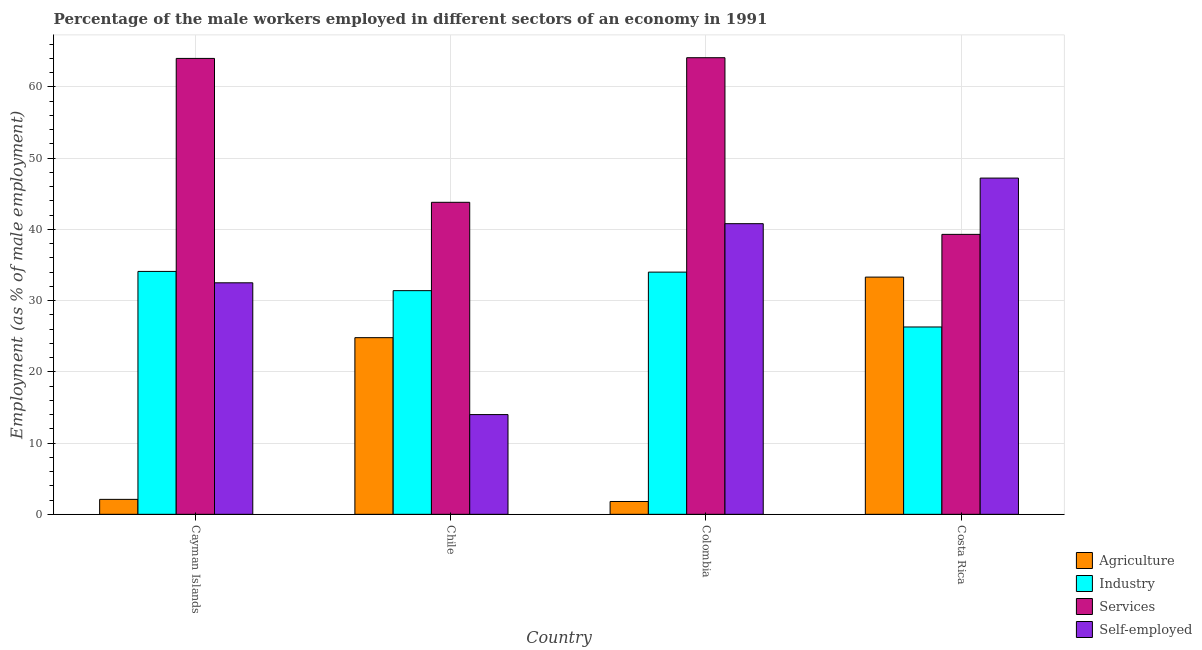How many different coloured bars are there?
Offer a very short reply. 4. Are the number of bars per tick equal to the number of legend labels?
Provide a short and direct response. Yes. Are the number of bars on each tick of the X-axis equal?
Keep it short and to the point. Yes. How many bars are there on the 4th tick from the left?
Provide a short and direct response. 4. How many bars are there on the 4th tick from the right?
Provide a succinct answer. 4. In how many cases, is the number of bars for a given country not equal to the number of legend labels?
Your answer should be compact. 0. What is the percentage of male workers in agriculture in Colombia?
Make the answer very short. 1.8. Across all countries, what is the maximum percentage of male workers in industry?
Offer a terse response. 34.1. In which country was the percentage of male workers in agriculture maximum?
Ensure brevity in your answer.  Costa Rica. In which country was the percentage of male workers in services minimum?
Offer a terse response. Costa Rica. What is the total percentage of male workers in agriculture in the graph?
Provide a succinct answer. 62. What is the difference between the percentage of self employed male workers in Chile and that in Costa Rica?
Provide a short and direct response. -33.2. What is the difference between the percentage of male workers in industry in Cayman Islands and the percentage of self employed male workers in Colombia?
Your answer should be compact. -6.7. What is the average percentage of male workers in services per country?
Give a very brief answer. 52.8. What is the difference between the percentage of male workers in services and percentage of male workers in industry in Chile?
Provide a short and direct response. 12.4. In how many countries, is the percentage of male workers in services greater than 28 %?
Your answer should be compact. 4. What is the ratio of the percentage of male workers in services in Cayman Islands to that in Costa Rica?
Your response must be concise. 1.63. Is the percentage of self employed male workers in Cayman Islands less than that in Costa Rica?
Keep it short and to the point. Yes. Is the difference between the percentage of male workers in agriculture in Colombia and Costa Rica greater than the difference between the percentage of male workers in services in Colombia and Costa Rica?
Offer a terse response. No. What is the difference between the highest and the second highest percentage of self employed male workers?
Provide a short and direct response. 6.4. What is the difference between the highest and the lowest percentage of self employed male workers?
Keep it short and to the point. 33.2. In how many countries, is the percentage of male workers in services greater than the average percentage of male workers in services taken over all countries?
Your answer should be very brief. 2. Is it the case that in every country, the sum of the percentage of self employed male workers and percentage of male workers in agriculture is greater than the sum of percentage of male workers in services and percentage of male workers in industry?
Provide a succinct answer. No. What does the 1st bar from the left in Chile represents?
Your response must be concise. Agriculture. What does the 4th bar from the right in Cayman Islands represents?
Give a very brief answer. Agriculture. Are all the bars in the graph horizontal?
Ensure brevity in your answer.  No. What is the difference between two consecutive major ticks on the Y-axis?
Your response must be concise. 10. Are the values on the major ticks of Y-axis written in scientific E-notation?
Ensure brevity in your answer.  No. Does the graph contain grids?
Provide a short and direct response. Yes. How many legend labels are there?
Keep it short and to the point. 4. What is the title of the graph?
Your response must be concise. Percentage of the male workers employed in different sectors of an economy in 1991. Does "Methodology assessment" appear as one of the legend labels in the graph?
Ensure brevity in your answer.  No. What is the label or title of the X-axis?
Offer a very short reply. Country. What is the label or title of the Y-axis?
Your response must be concise. Employment (as % of male employment). What is the Employment (as % of male employment) in Agriculture in Cayman Islands?
Make the answer very short. 2.1. What is the Employment (as % of male employment) in Industry in Cayman Islands?
Offer a terse response. 34.1. What is the Employment (as % of male employment) in Services in Cayman Islands?
Your response must be concise. 64. What is the Employment (as % of male employment) of Self-employed in Cayman Islands?
Your answer should be compact. 32.5. What is the Employment (as % of male employment) in Agriculture in Chile?
Your response must be concise. 24.8. What is the Employment (as % of male employment) in Industry in Chile?
Your answer should be very brief. 31.4. What is the Employment (as % of male employment) of Services in Chile?
Your response must be concise. 43.8. What is the Employment (as % of male employment) in Agriculture in Colombia?
Your response must be concise. 1.8. What is the Employment (as % of male employment) of Industry in Colombia?
Ensure brevity in your answer.  34. What is the Employment (as % of male employment) of Services in Colombia?
Your answer should be very brief. 64.1. What is the Employment (as % of male employment) in Self-employed in Colombia?
Provide a short and direct response. 40.8. What is the Employment (as % of male employment) in Agriculture in Costa Rica?
Ensure brevity in your answer.  33.3. What is the Employment (as % of male employment) of Industry in Costa Rica?
Offer a terse response. 26.3. What is the Employment (as % of male employment) of Services in Costa Rica?
Offer a terse response. 39.3. What is the Employment (as % of male employment) of Self-employed in Costa Rica?
Make the answer very short. 47.2. Across all countries, what is the maximum Employment (as % of male employment) in Agriculture?
Make the answer very short. 33.3. Across all countries, what is the maximum Employment (as % of male employment) of Industry?
Keep it short and to the point. 34.1. Across all countries, what is the maximum Employment (as % of male employment) in Services?
Make the answer very short. 64.1. Across all countries, what is the maximum Employment (as % of male employment) of Self-employed?
Your response must be concise. 47.2. Across all countries, what is the minimum Employment (as % of male employment) in Agriculture?
Your answer should be compact. 1.8. Across all countries, what is the minimum Employment (as % of male employment) in Industry?
Provide a succinct answer. 26.3. Across all countries, what is the minimum Employment (as % of male employment) of Services?
Your answer should be very brief. 39.3. Across all countries, what is the minimum Employment (as % of male employment) in Self-employed?
Provide a succinct answer. 14. What is the total Employment (as % of male employment) of Agriculture in the graph?
Keep it short and to the point. 62. What is the total Employment (as % of male employment) of Industry in the graph?
Provide a short and direct response. 125.8. What is the total Employment (as % of male employment) in Services in the graph?
Your answer should be very brief. 211.2. What is the total Employment (as % of male employment) of Self-employed in the graph?
Your answer should be compact. 134.5. What is the difference between the Employment (as % of male employment) in Agriculture in Cayman Islands and that in Chile?
Provide a succinct answer. -22.7. What is the difference between the Employment (as % of male employment) of Services in Cayman Islands and that in Chile?
Your answer should be compact. 20.2. What is the difference between the Employment (as % of male employment) of Agriculture in Cayman Islands and that in Colombia?
Provide a succinct answer. 0.3. What is the difference between the Employment (as % of male employment) of Industry in Cayman Islands and that in Colombia?
Provide a succinct answer. 0.1. What is the difference between the Employment (as % of male employment) in Self-employed in Cayman Islands and that in Colombia?
Your answer should be compact. -8.3. What is the difference between the Employment (as % of male employment) in Agriculture in Cayman Islands and that in Costa Rica?
Make the answer very short. -31.2. What is the difference between the Employment (as % of male employment) of Services in Cayman Islands and that in Costa Rica?
Provide a short and direct response. 24.7. What is the difference between the Employment (as % of male employment) of Self-employed in Cayman Islands and that in Costa Rica?
Keep it short and to the point. -14.7. What is the difference between the Employment (as % of male employment) of Agriculture in Chile and that in Colombia?
Keep it short and to the point. 23. What is the difference between the Employment (as % of male employment) in Industry in Chile and that in Colombia?
Provide a short and direct response. -2.6. What is the difference between the Employment (as % of male employment) of Services in Chile and that in Colombia?
Ensure brevity in your answer.  -20.3. What is the difference between the Employment (as % of male employment) in Self-employed in Chile and that in Colombia?
Provide a short and direct response. -26.8. What is the difference between the Employment (as % of male employment) in Agriculture in Chile and that in Costa Rica?
Ensure brevity in your answer.  -8.5. What is the difference between the Employment (as % of male employment) of Industry in Chile and that in Costa Rica?
Your answer should be compact. 5.1. What is the difference between the Employment (as % of male employment) in Self-employed in Chile and that in Costa Rica?
Give a very brief answer. -33.2. What is the difference between the Employment (as % of male employment) in Agriculture in Colombia and that in Costa Rica?
Give a very brief answer. -31.5. What is the difference between the Employment (as % of male employment) of Industry in Colombia and that in Costa Rica?
Your response must be concise. 7.7. What is the difference between the Employment (as % of male employment) in Services in Colombia and that in Costa Rica?
Your answer should be very brief. 24.8. What is the difference between the Employment (as % of male employment) in Self-employed in Colombia and that in Costa Rica?
Give a very brief answer. -6.4. What is the difference between the Employment (as % of male employment) of Agriculture in Cayman Islands and the Employment (as % of male employment) of Industry in Chile?
Make the answer very short. -29.3. What is the difference between the Employment (as % of male employment) of Agriculture in Cayman Islands and the Employment (as % of male employment) of Services in Chile?
Make the answer very short. -41.7. What is the difference between the Employment (as % of male employment) in Industry in Cayman Islands and the Employment (as % of male employment) in Self-employed in Chile?
Your answer should be very brief. 20.1. What is the difference between the Employment (as % of male employment) of Agriculture in Cayman Islands and the Employment (as % of male employment) of Industry in Colombia?
Provide a succinct answer. -31.9. What is the difference between the Employment (as % of male employment) of Agriculture in Cayman Islands and the Employment (as % of male employment) of Services in Colombia?
Offer a terse response. -62. What is the difference between the Employment (as % of male employment) in Agriculture in Cayman Islands and the Employment (as % of male employment) in Self-employed in Colombia?
Your answer should be compact. -38.7. What is the difference between the Employment (as % of male employment) of Industry in Cayman Islands and the Employment (as % of male employment) of Services in Colombia?
Your answer should be compact. -30. What is the difference between the Employment (as % of male employment) in Industry in Cayman Islands and the Employment (as % of male employment) in Self-employed in Colombia?
Provide a short and direct response. -6.7. What is the difference between the Employment (as % of male employment) in Services in Cayman Islands and the Employment (as % of male employment) in Self-employed in Colombia?
Make the answer very short. 23.2. What is the difference between the Employment (as % of male employment) in Agriculture in Cayman Islands and the Employment (as % of male employment) in Industry in Costa Rica?
Your answer should be very brief. -24.2. What is the difference between the Employment (as % of male employment) in Agriculture in Cayman Islands and the Employment (as % of male employment) in Services in Costa Rica?
Offer a terse response. -37.2. What is the difference between the Employment (as % of male employment) of Agriculture in Cayman Islands and the Employment (as % of male employment) of Self-employed in Costa Rica?
Offer a very short reply. -45.1. What is the difference between the Employment (as % of male employment) in Industry in Cayman Islands and the Employment (as % of male employment) in Self-employed in Costa Rica?
Your answer should be very brief. -13.1. What is the difference between the Employment (as % of male employment) in Services in Cayman Islands and the Employment (as % of male employment) in Self-employed in Costa Rica?
Your response must be concise. 16.8. What is the difference between the Employment (as % of male employment) of Agriculture in Chile and the Employment (as % of male employment) of Services in Colombia?
Make the answer very short. -39.3. What is the difference between the Employment (as % of male employment) in Agriculture in Chile and the Employment (as % of male employment) in Self-employed in Colombia?
Make the answer very short. -16. What is the difference between the Employment (as % of male employment) of Industry in Chile and the Employment (as % of male employment) of Services in Colombia?
Offer a very short reply. -32.7. What is the difference between the Employment (as % of male employment) in Services in Chile and the Employment (as % of male employment) in Self-employed in Colombia?
Offer a very short reply. 3. What is the difference between the Employment (as % of male employment) of Agriculture in Chile and the Employment (as % of male employment) of Services in Costa Rica?
Provide a succinct answer. -14.5. What is the difference between the Employment (as % of male employment) of Agriculture in Chile and the Employment (as % of male employment) of Self-employed in Costa Rica?
Offer a very short reply. -22.4. What is the difference between the Employment (as % of male employment) of Industry in Chile and the Employment (as % of male employment) of Services in Costa Rica?
Offer a very short reply. -7.9. What is the difference between the Employment (as % of male employment) of Industry in Chile and the Employment (as % of male employment) of Self-employed in Costa Rica?
Your answer should be very brief. -15.8. What is the difference between the Employment (as % of male employment) in Services in Chile and the Employment (as % of male employment) in Self-employed in Costa Rica?
Ensure brevity in your answer.  -3.4. What is the difference between the Employment (as % of male employment) of Agriculture in Colombia and the Employment (as % of male employment) of Industry in Costa Rica?
Offer a very short reply. -24.5. What is the difference between the Employment (as % of male employment) of Agriculture in Colombia and the Employment (as % of male employment) of Services in Costa Rica?
Offer a terse response. -37.5. What is the difference between the Employment (as % of male employment) in Agriculture in Colombia and the Employment (as % of male employment) in Self-employed in Costa Rica?
Provide a short and direct response. -45.4. What is the difference between the Employment (as % of male employment) of Industry in Colombia and the Employment (as % of male employment) of Services in Costa Rica?
Offer a terse response. -5.3. What is the difference between the Employment (as % of male employment) of Industry in Colombia and the Employment (as % of male employment) of Self-employed in Costa Rica?
Make the answer very short. -13.2. What is the difference between the Employment (as % of male employment) in Services in Colombia and the Employment (as % of male employment) in Self-employed in Costa Rica?
Your response must be concise. 16.9. What is the average Employment (as % of male employment) in Agriculture per country?
Make the answer very short. 15.5. What is the average Employment (as % of male employment) of Industry per country?
Provide a succinct answer. 31.45. What is the average Employment (as % of male employment) in Services per country?
Give a very brief answer. 52.8. What is the average Employment (as % of male employment) in Self-employed per country?
Offer a very short reply. 33.62. What is the difference between the Employment (as % of male employment) of Agriculture and Employment (as % of male employment) of Industry in Cayman Islands?
Your answer should be compact. -32. What is the difference between the Employment (as % of male employment) in Agriculture and Employment (as % of male employment) in Services in Cayman Islands?
Offer a very short reply. -61.9. What is the difference between the Employment (as % of male employment) of Agriculture and Employment (as % of male employment) of Self-employed in Cayman Islands?
Provide a succinct answer. -30.4. What is the difference between the Employment (as % of male employment) of Industry and Employment (as % of male employment) of Services in Cayman Islands?
Offer a terse response. -29.9. What is the difference between the Employment (as % of male employment) of Industry and Employment (as % of male employment) of Self-employed in Cayman Islands?
Ensure brevity in your answer.  1.6. What is the difference between the Employment (as % of male employment) of Services and Employment (as % of male employment) of Self-employed in Cayman Islands?
Ensure brevity in your answer.  31.5. What is the difference between the Employment (as % of male employment) in Industry and Employment (as % of male employment) in Self-employed in Chile?
Offer a very short reply. 17.4. What is the difference between the Employment (as % of male employment) of Services and Employment (as % of male employment) of Self-employed in Chile?
Ensure brevity in your answer.  29.8. What is the difference between the Employment (as % of male employment) in Agriculture and Employment (as % of male employment) in Industry in Colombia?
Provide a short and direct response. -32.2. What is the difference between the Employment (as % of male employment) of Agriculture and Employment (as % of male employment) of Services in Colombia?
Your response must be concise. -62.3. What is the difference between the Employment (as % of male employment) of Agriculture and Employment (as % of male employment) of Self-employed in Colombia?
Ensure brevity in your answer.  -39. What is the difference between the Employment (as % of male employment) in Industry and Employment (as % of male employment) in Services in Colombia?
Keep it short and to the point. -30.1. What is the difference between the Employment (as % of male employment) in Services and Employment (as % of male employment) in Self-employed in Colombia?
Offer a terse response. 23.3. What is the difference between the Employment (as % of male employment) of Agriculture and Employment (as % of male employment) of Industry in Costa Rica?
Offer a terse response. 7. What is the difference between the Employment (as % of male employment) in Agriculture and Employment (as % of male employment) in Services in Costa Rica?
Give a very brief answer. -6. What is the difference between the Employment (as % of male employment) of Industry and Employment (as % of male employment) of Self-employed in Costa Rica?
Offer a very short reply. -20.9. What is the ratio of the Employment (as % of male employment) of Agriculture in Cayman Islands to that in Chile?
Your answer should be compact. 0.08. What is the ratio of the Employment (as % of male employment) of Industry in Cayman Islands to that in Chile?
Offer a very short reply. 1.09. What is the ratio of the Employment (as % of male employment) of Services in Cayman Islands to that in Chile?
Offer a very short reply. 1.46. What is the ratio of the Employment (as % of male employment) of Self-employed in Cayman Islands to that in Chile?
Ensure brevity in your answer.  2.32. What is the ratio of the Employment (as % of male employment) in Industry in Cayman Islands to that in Colombia?
Offer a terse response. 1. What is the ratio of the Employment (as % of male employment) of Services in Cayman Islands to that in Colombia?
Your answer should be very brief. 1. What is the ratio of the Employment (as % of male employment) in Self-employed in Cayman Islands to that in Colombia?
Your response must be concise. 0.8. What is the ratio of the Employment (as % of male employment) in Agriculture in Cayman Islands to that in Costa Rica?
Offer a very short reply. 0.06. What is the ratio of the Employment (as % of male employment) in Industry in Cayman Islands to that in Costa Rica?
Give a very brief answer. 1.3. What is the ratio of the Employment (as % of male employment) in Services in Cayman Islands to that in Costa Rica?
Make the answer very short. 1.63. What is the ratio of the Employment (as % of male employment) of Self-employed in Cayman Islands to that in Costa Rica?
Provide a short and direct response. 0.69. What is the ratio of the Employment (as % of male employment) in Agriculture in Chile to that in Colombia?
Offer a very short reply. 13.78. What is the ratio of the Employment (as % of male employment) in Industry in Chile to that in Colombia?
Ensure brevity in your answer.  0.92. What is the ratio of the Employment (as % of male employment) in Services in Chile to that in Colombia?
Offer a terse response. 0.68. What is the ratio of the Employment (as % of male employment) in Self-employed in Chile to that in Colombia?
Keep it short and to the point. 0.34. What is the ratio of the Employment (as % of male employment) in Agriculture in Chile to that in Costa Rica?
Your answer should be compact. 0.74. What is the ratio of the Employment (as % of male employment) in Industry in Chile to that in Costa Rica?
Your response must be concise. 1.19. What is the ratio of the Employment (as % of male employment) in Services in Chile to that in Costa Rica?
Provide a succinct answer. 1.11. What is the ratio of the Employment (as % of male employment) of Self-employed in Chile to that in Costa Rica?
Provide a short and direct response. 0.3. What is the ratio of the Employment (as % of male employment) of Agriculture in Colombia to that in Costa Rica?
Offer a terse response. 0.05. What is the ratio of the Employment (as % of male employment) in Industry in Colombia to that in Costa Rica?
Provide a short and direct response. 1.29. What is the ratio of the Employment (as % of male employment) in Services in Colombia to that in Costa Rica?
Ensure brevity in your answer.  1.63. What is the ratio of the Employment (as % of male employment) of Self-employed in Colombia to that in Costa Rica?
Provide a succinct answer. 0.86. What is the difference between the highest and the second highest Employment (as % of male employment) of Services?
Keep it short and to the point. 0.1. What is the difference between the highest and the lowest Employment (as % of male employment) of Agriculture?
Offer a terse response. 31.5. What is the difference between the highest and the lowest Employment (as % of male employment) of Services?
Provide a succinct answer. 24.8. What is the difference between the highest and the lowest Employment (as % of male employment) in Self-employed?
Make the answer very short. 33.2. 